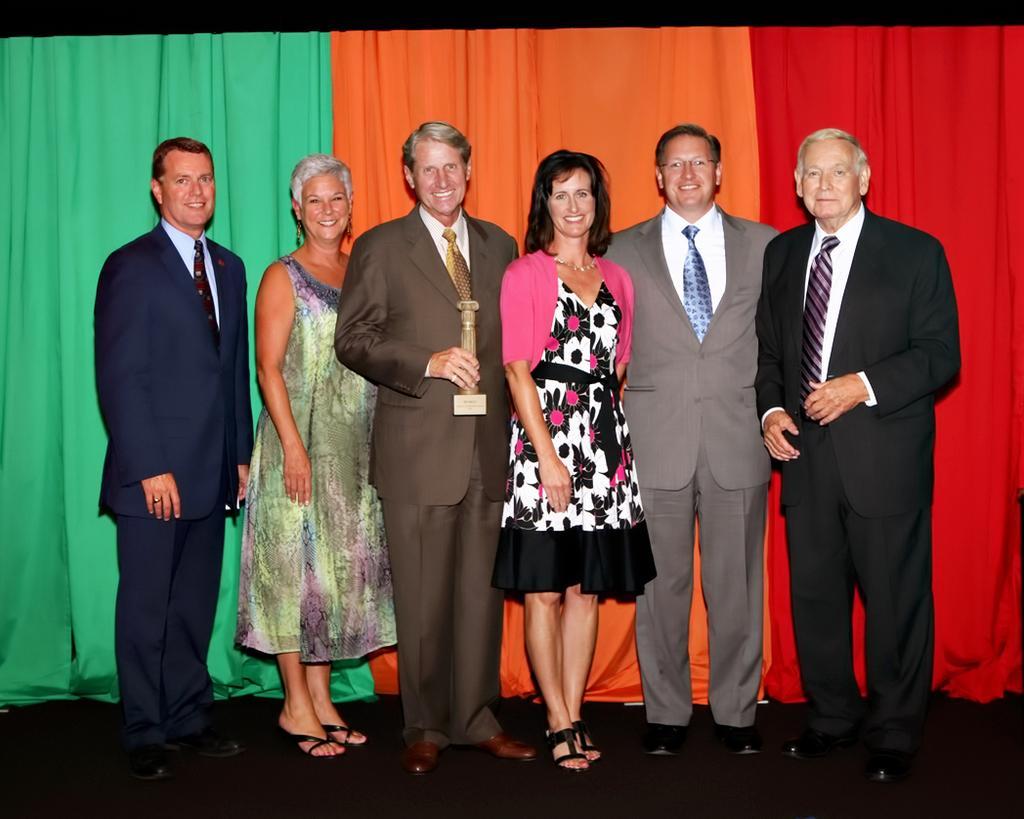Could you give a brief overview of what you see in this image? In the picture we can see some people are standing and giving a pose to the photograph, they all are smiling and one person is holding an award, in the background we can see a curtain which is green, orange and red in color. 